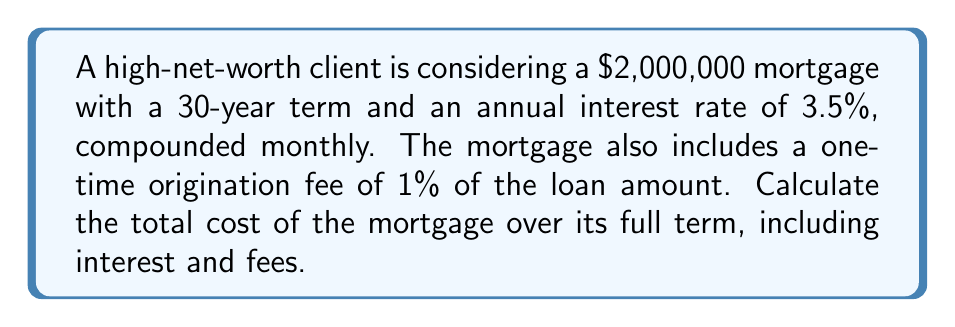Can you solve this math problem? Let's break this down step-by-step:

1) First, calculate the origination fee:
   $\text{Origination Fee} = 1\% \times \$2,000,000 = \$20,000$

2) Now, let's calculate the monthly payment using the mortgage payment formula:
   $P = L\frac{r(1+r)^n}{(1+r)^n-1}$

   Where:
   $P$ = monthly payment
   $L$ = loan amount ($2,000,000)
   $r$ = monthly interest rate (3.5% / 12 = 0.02917%)
   $n$ = total number of months (30 years * 12 = 360)

   $P = 2,000,000 \times \frac{0.0002917(1+0.0002917)^{360}}{(1+0.0002917)^{360}-1}$

   $P = \$8,977.78$

3) Calculate the total amount paid over the life of the loan:
   $\text{Total Payments} = \text{Monthly Payment} \times \text{Number of Months}$
   $\text{Total Payments} = \$8,977.78 \times 360 = \$3,232,000.80$

4) Calculate the total interest paid:
   $\text{Total Interest} = \text{Total Payments} - \text{Loan Amount}$
   $\text{Total Interest} = \$3,232,000.80 - \$2,000,000 = \$1,232,000.80$

5) Sum up all costs:
   $\text{Total Cost} = \text{Loan Amount} + \text{Total Interest} + \text{Origination Fee}$
   $\text{Total Cost} = \$2,000,000 + \$1,232,000.80 + \$20,000 = \$3,252,000.80$
Answer: $\$3,252,000.80$ 